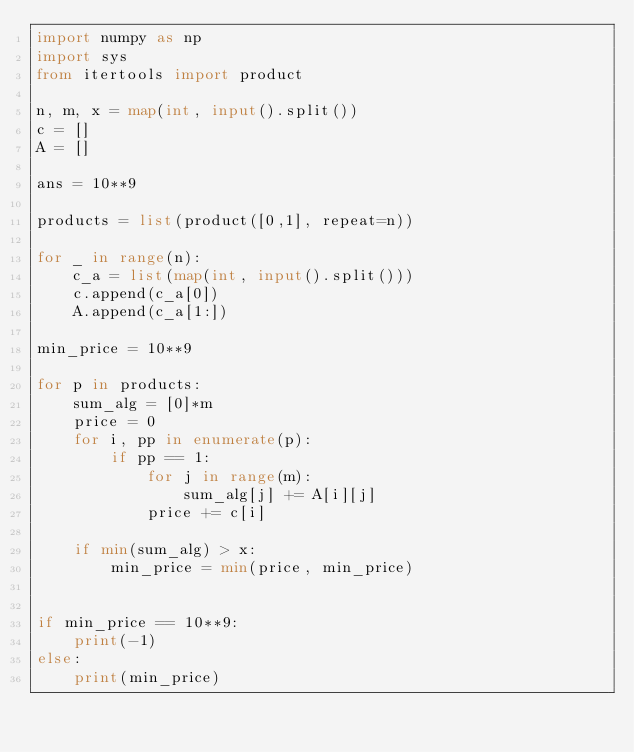<code> <loc_0><loc_0><loc_500><loc_500><_Python_>import numpy as np
import sys
from itertools import product

n, m, x = map(int, input().split())
c = []
A = []

ans = 10**9

products = list(product([0,1], repeat=n))

for _ in range(n):
    c_a = list(map(int, input().split()))
    c.append(c_a[0])
    A.append(c_a[1:])

min_price = 10**9

for p in products:
    sum_alg = [0]*m
    price = 0
    for i, pp in enumerate(p):
        if pp == 1:
            for j in range(m):
                sum_alg[j] += A[i][j]
            price += c[i]

    if min(sum_alg) > x: 
        min_price = min(price, min_price)


if min_price == 10**9:
    print(-1)
else:
    print(min_price)



</code> 